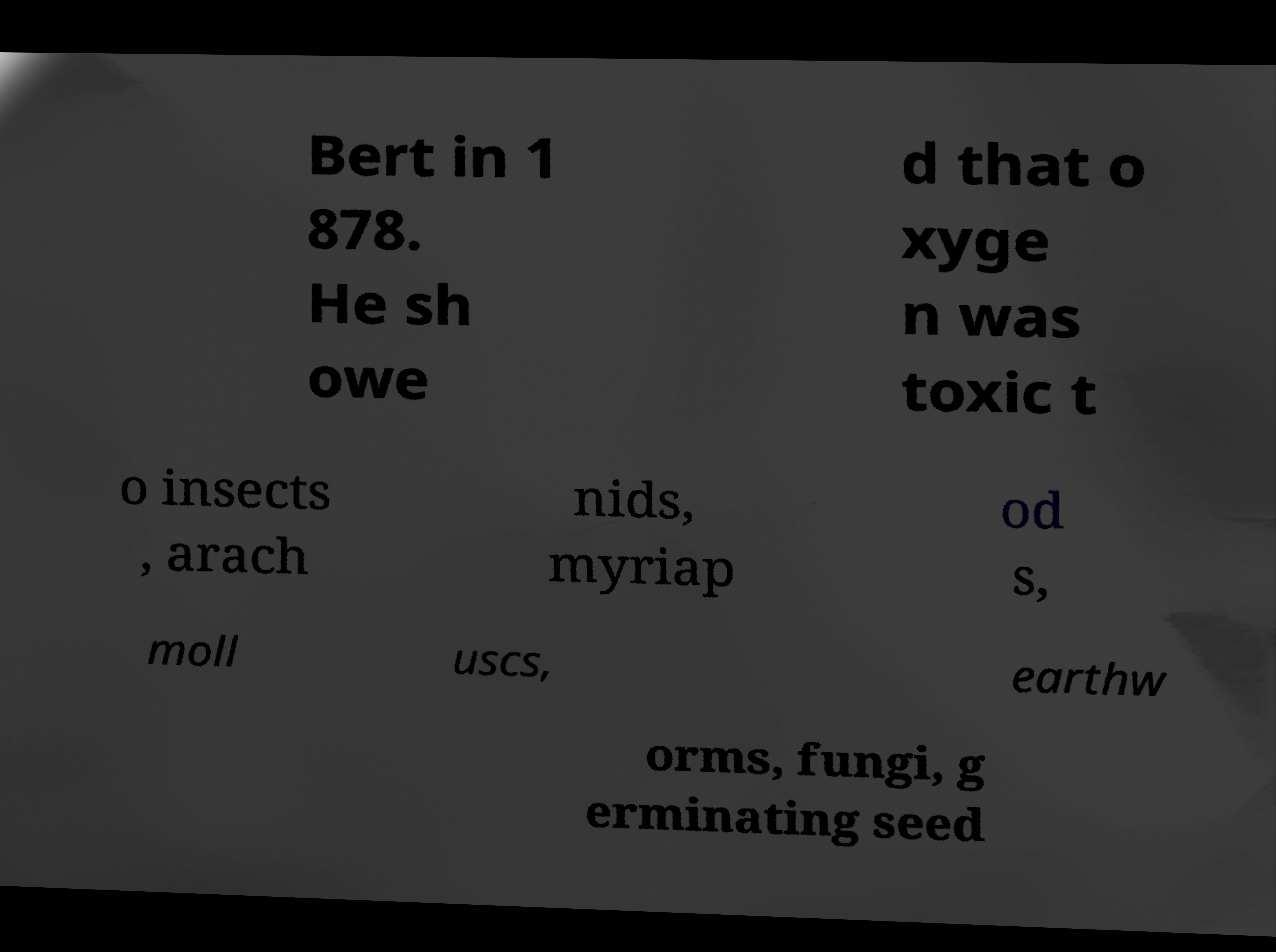Please read and relay the text visible in this image. What does it say? Bert in 1 878. He sh owe d that o xyge n was toxic t o insects , arach nids, myriap od s, moll uscs, earthw orms, fungi, g erminating seed 